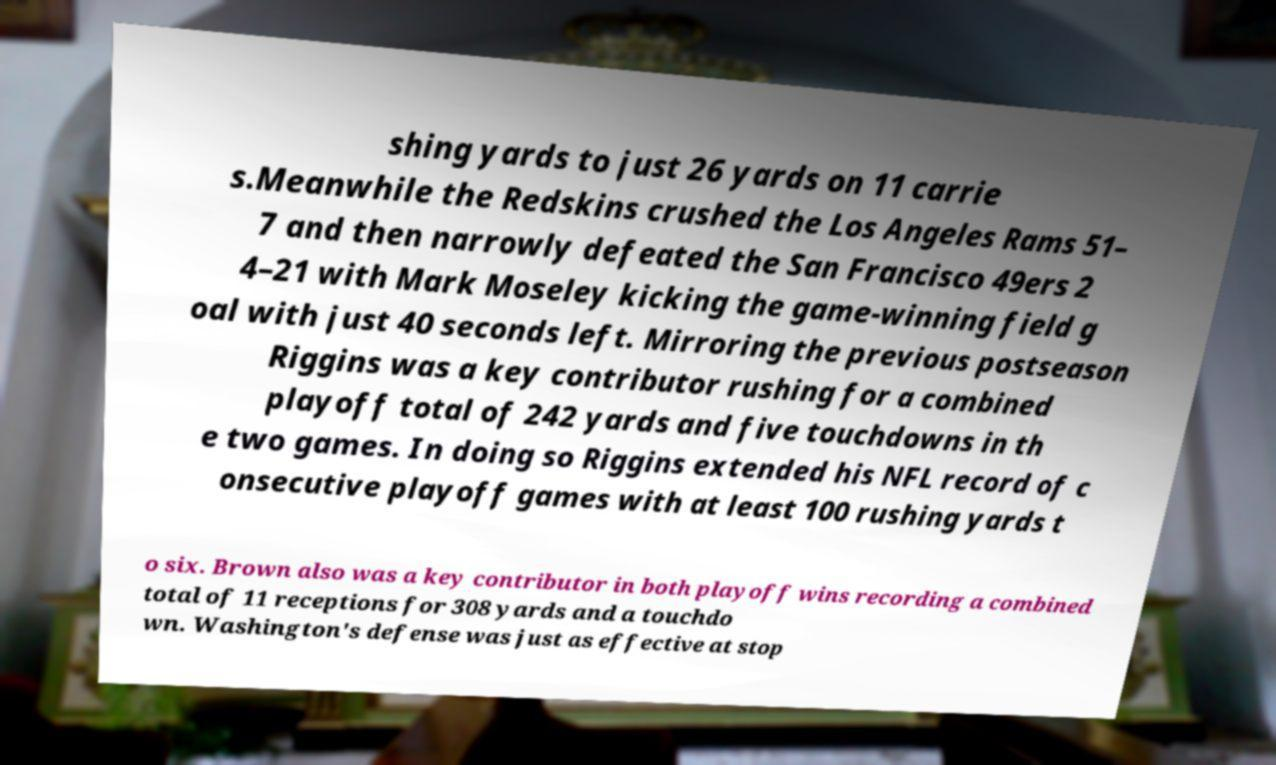Please read and relay the text visible in this image. What does it say? shing yards to just 26 yards on 11 carrie s.Meanwhile the Redskins crushed the Los Angeles Rams 51– 7 and then narrowly defeated the San Francisco 49ers 2 4–21 with Mark Moseley kicking the game-winning field g oal with just 40 seconds left. Mirroring the previous postseason Riggins was a key contributor rushing for a combined playoff total of 242 yards and five touchdowns in th e two games. In doing so Riggins extended his NFL record of c onsecutive playoff games with at least 100 rushing yards t o six. Brown also was a key contributor in both playoff wins recording a combined total of 11 receptions for 308 yards and a touchdo wn. Washington's defense was just as effective at stop 